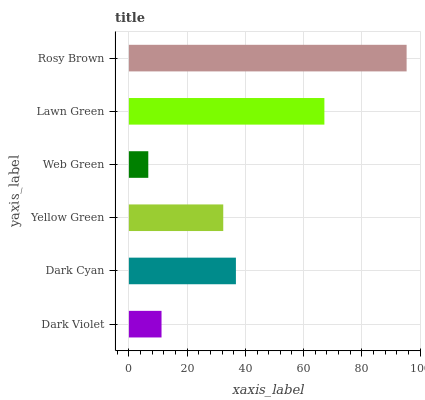Is Web Green the minimum?
Answer yes or no. Yes. Is Rosy Brown the maximum?
Answer yes or no. Yes. Is Dark Cyan the minimum?
Answer yes or no. No. Is Dark Cyan the maximum?
Answer yes or no. No. Is Dark Cyan greater than Dark Violet?
Answer yes or no. Yes. Is Dark Violet less than Dark Cyan?
Answer yes or no. Yes. Is Dark Violet greater than Dark Cyan?
Answer yes or no. No. Is Dark Cyan less than Dark Violet?
Answer yes or no. No. Is Dark Cyan the high median?
Answer yes or no. Yes. Is Yellow Green the low median?
Answer yes or no. Yes. Is Yellow Green the high median?
Answer yes or no. No. Is Web Green the low median?
Answer yes or no. No. 